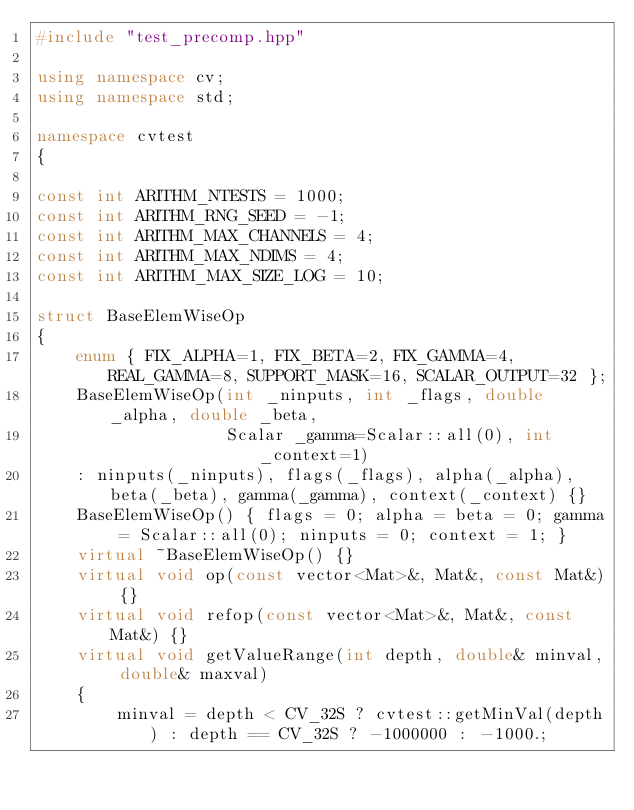Convert code to text. <code><loc_0><loc_0><loc_500><loc_500><_C++_>#include "test_precomp.hpp"

using namespace cv;
using namespace std;

namespace cvtest
{

const int ARITHM_NTESTS = 1000;
const int ARITHM_RNG_SEED = -1;
const int ARITHM_MAX_CHANNELS = 4;
const int ARITHM_MAX_NDIMS = 4;
const int ARITHM_MAX_SIZE_LOG = 10;

struct BaseElemWiseOp
{
    enum { FIX_ALPHA=1, FIX_BETA=2, FIX_GAMMA=4, REAL_GAMMA=8, SUPPORT_MASK=16, SCALAR_OUTPUT=32 };
    BaseElemWiseOp(int _ninputs, int _flags, double _alpha, double _beta,
                   Scalar _gamma=Scalar::all(0), int _context=1)
    : ninputs(_ninputs), flags(_flags), alpha(_alpha), beta(_beta), gamma(_gamma), context(_context) {}
    BaseElemWiseOp() { flags = 0; alpha = beta = 0; gamma = Scalar::all(0); ninputs = 0; context = 1; }
    virtual ~BaseElemWiseOp() {}
    virtual void op(const vector<Mat>&, Mat&, const Mat&) {}
    virtual void refop(const vector<Mat>&, Mat&, const Mat&) {}
    virtual void getValueRange(int depth, double& minval, double& maxval)
    {
        minval = depth < CV_32S ? cvtest::getMinVal(depth) : depth == CV_32S ? -1000000 : -1000.;</code> 